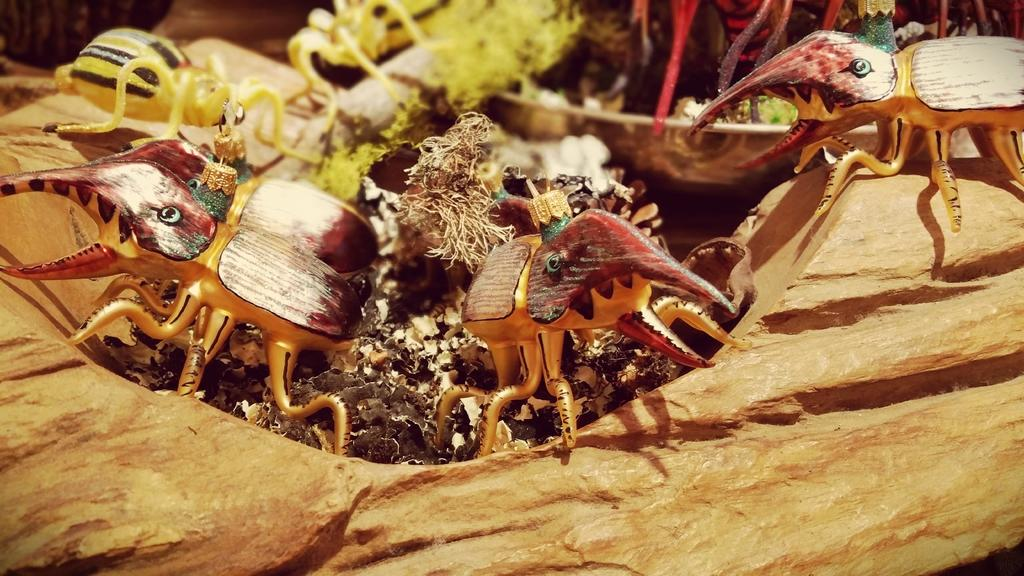What type of toys are present in the image? There are toy insects in the image. What surface are the toy insects placed on? The toy insects are on a brown object. What material is the object in the background made of? The object in the background is made of steel. Can you describe any other elements in the background of the image? There are other unspecified elements in the background of the image. What is your dad's weight, and is he present in the image? Your dad's weight is not mentioned in the image, and there is no indication that he is present in the image. 